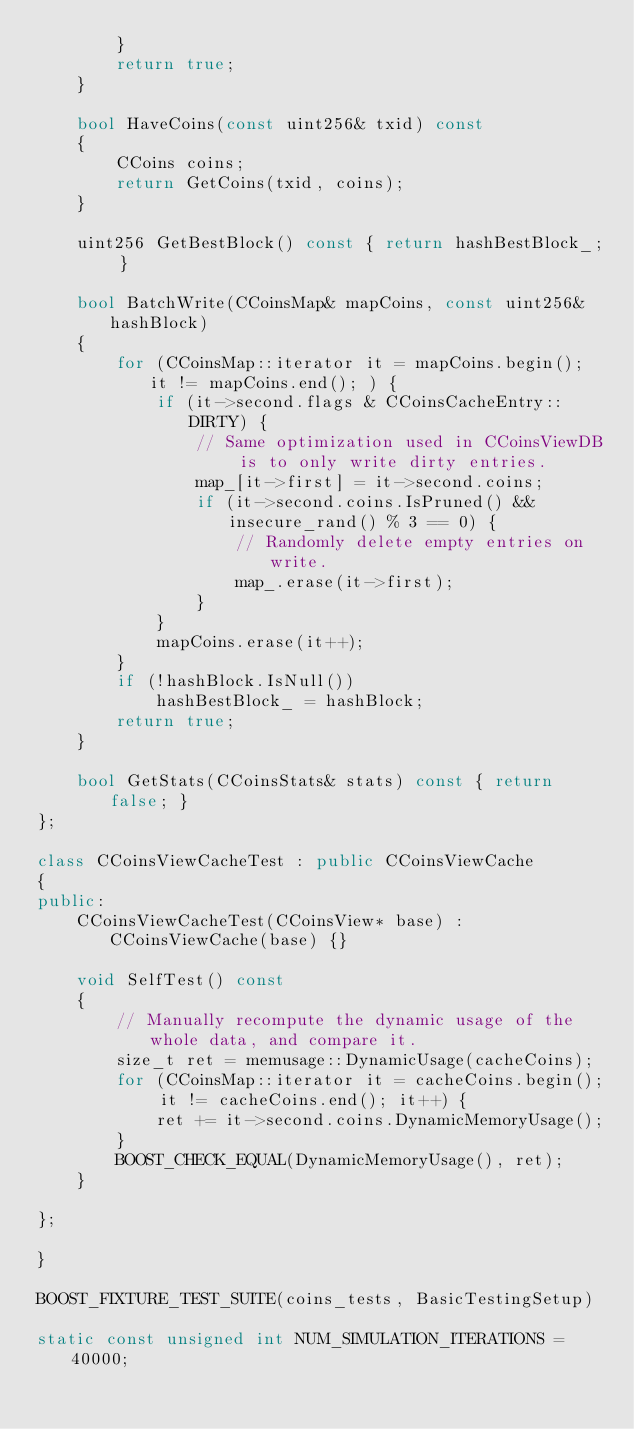<code> <loc_0><loc_0><loc_500><loc_500><_C++_>        }
        return true;
    }

    bool HaveCoins(const uint256& txid) const
    {
        CCoins coins;
        return GetCoins(txid, coins);
    }

    uint256 GetBestBlock() const { return hashBestBlock_; }

    bool BatchWrite(CCoinsMap& mapCoins, const uint256& hashBlock)
    {
        for (CCoinsMap::iterator it = mapCoins.begin(); it != mapCoins.end(); ) {
            if (it->second.flags & CCoinsCacheEntry::DIRTY) {
                // Same optimization used in CCoinsViewDB is to only write dirty entries.
                map_[it->first] = it->second.coins;
                if (it->second.coins.IsPruned() && insecure_rand() % 3 == 0) {
                    // Randomly delete empty entries on write.
                    map_.erase(it->first);
                }
            }
            mapCoins.erase(it++);
        }
        if (!hashBlock.IsNull())
            hashBestBlock_ = hashBlock;
        return true;
    }

    bool GetStats(CCoinsStats& stats) const { return false; }
};

class CCoinsViewCacheTest : public CCoinsViewCache
{
public:
    CCoinsViewCacheTest(CCoinsView* base) : CCoinsViewCache(base) {}

    void SelfTest() const
    {
        // Manually recompute the dynamic usage of the whole data, and compare it.
        size_t ret = memusage::DynamicUsage(cacheCoins);
        for (CCoinsMap::iterator it = cacheCoins.begin(); it != cacheCoins.end(); it++) {
            ret += it->second.coins.DynamicMemoryUsage();
        }
        BOOST_CHECK_EQUAL(DynamicMemoryUsage(), ret);
    }

};

}

BOOST_FIXTURE_TEST_SUITE(coins_tests, BasicTestingSetup)

static const unsigned int NUM_SIMULATION_ITERATIONS = 40000;
</code> 